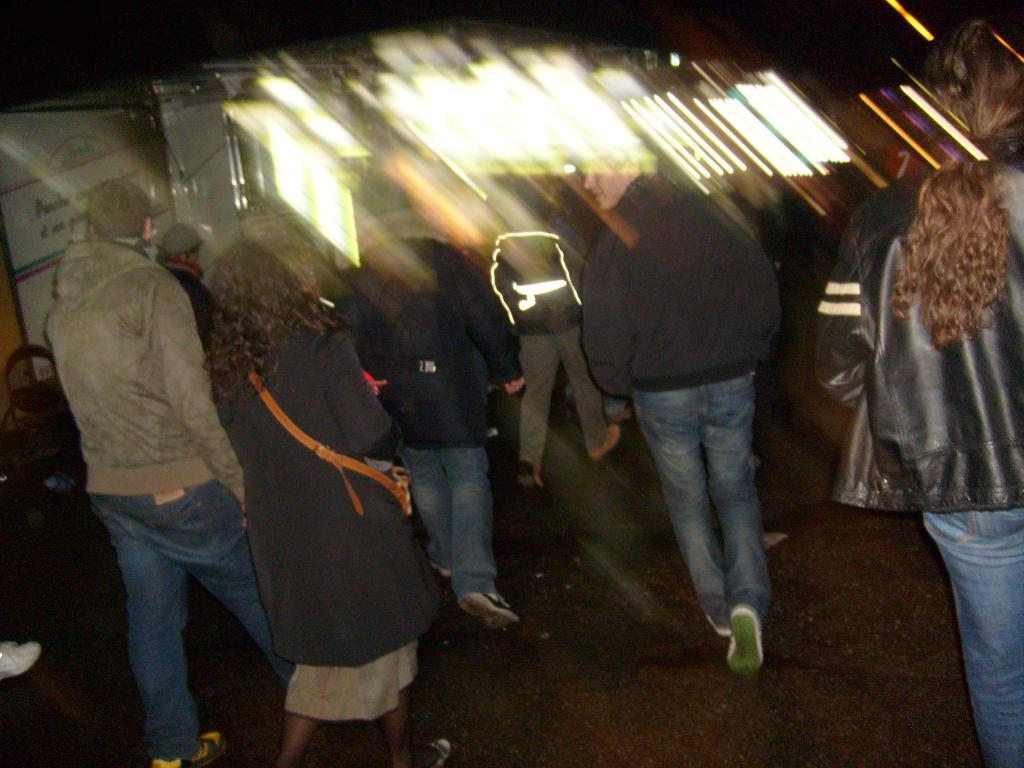Please provide a concise description of this image. In this image there are few people walking on the road. The background is blurred. 